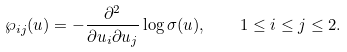Convert formula to latex. <formula><loc_0><loc_0><loc_500><loc_500>\wp _ { i j } ( u ) = - \frac { \partial ^ { 2 } } { \partial u _ { i } \partial u _ { j } } \log \sigma ( u ) , \quad 1 \leq i \leq j \leq 2 .</formula> 